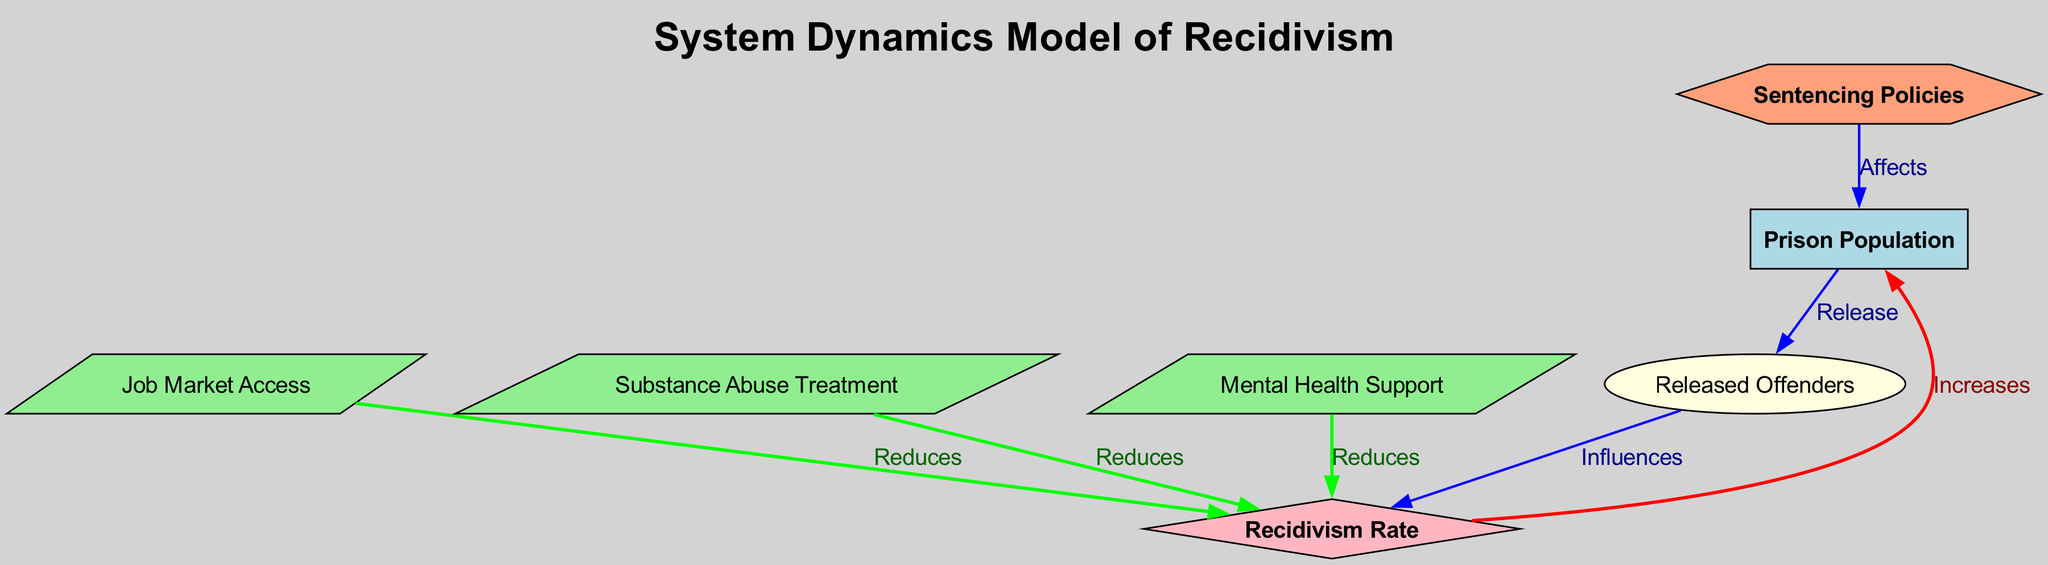What are the total number of nodes in the diagram? The diagram lists seven nodes, each representing a component of the system dynamics model related to recidivism and prison populations.
Answer: 7 How does Job Market Access affect the Recidivism Rate? Job Market Access has a directed edge labeled "Reduces" leading to Recidivism Rate, indicating that increased access to the job market contributes to a decrease in the recidivism rate.
Answer: Reduces What are the components that positively influence the Recidivism Rate? The Recidivism Rate is influenced by Released Offenders, which connects to it with an "Influences" edge, while other connections labeled "Reduces" from Job Market Access, Substance Abuse Treatment, and Mental Health Support indicate they all work to lower the rate.
Answer: Released Offenders Which node has a relationship labeled "Affects" with the Prison Population? The edge from Sentencing Policies to Prison Population is labeled "Affects," showing that changes in sentencing policies have an impact on the number of individuals in prison.
Answer: Sentencing Policies What is the relationship labeled "Increases" between two nodes? The edge from Recidivism Rate to Prison Population is labeled "Increases," indicating that as the recidivism rate rises, the prison population also increases as a consequence.
Answer: Increases How many intervention points are identified in the diagram that reduce the Recidivism Rate? There are three nodes—Job Market Access, Substance Abuse Treatment, and Mental Health Support—that have edges labeled "Reduces," implying intervention points that could decrease recidivism.
Answer: 3 Which node is the starting point for the loop of recidivism affecting prison population? The loop begins with Prison Population flowing to Released Offenders, and then the cycle returns through Recidivism Rate, indicating a cyclical relationship.
Answer: Prison Population What effect do Sentencing Policies have on the Prison Population? The directed edge from Sentencing Policies to Prison Population indicates that sentencing policies can significantly impact the number of individuals incarcerated.
Answer: Affects 